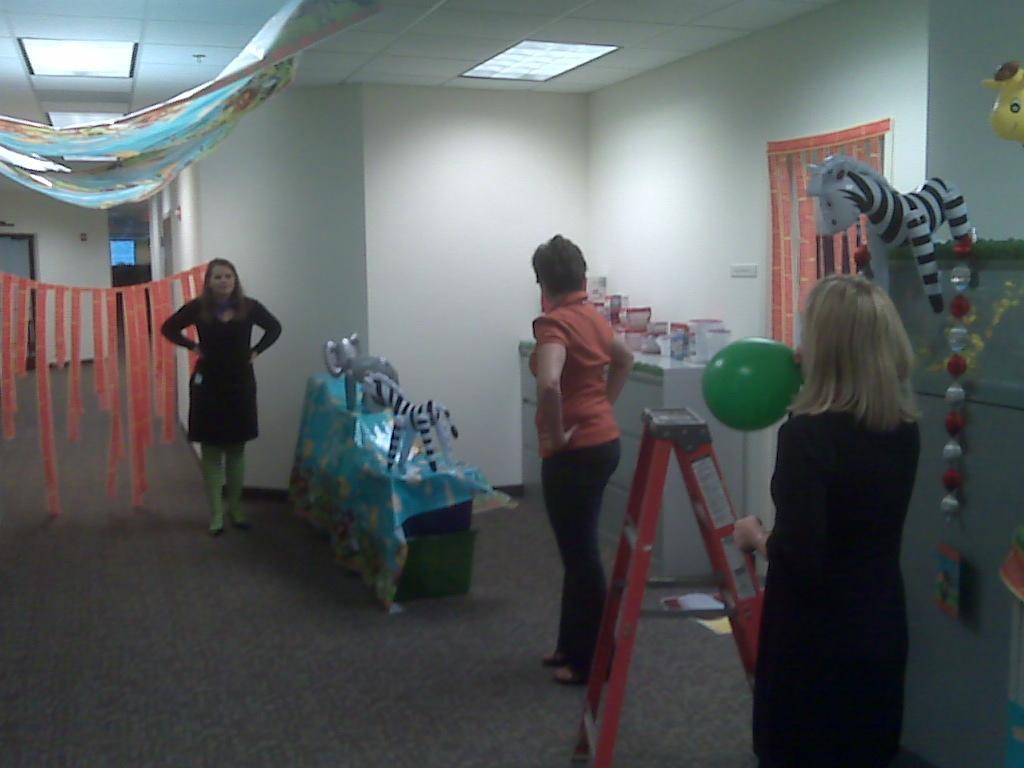Could you give a brief overview of what you see in this image? In this picture there are people and we can see toys, stand, decorative items, wall, floor and objects. At the top of the image we can see ceiling and lights. 